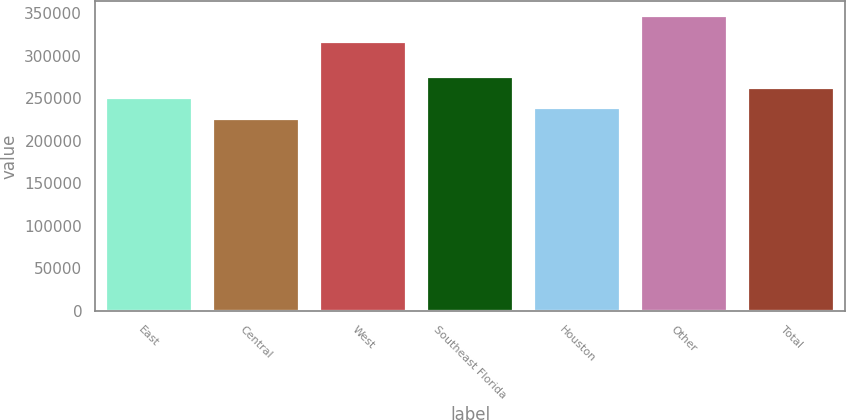Convert chart. <chart><loc_0><loc_0><loc_500><loc_500><bar_chart><fcel>East<fcel>Central<fcel>West<fcel>Southeast Florida<fcel>Houston<fcel>Other<fcel>Total<nl><fcel>250200<fcel>226000<fcel>316000<fcel>274400<fcel>238100<fcel>347000<fcel>262300<nl></chart> 